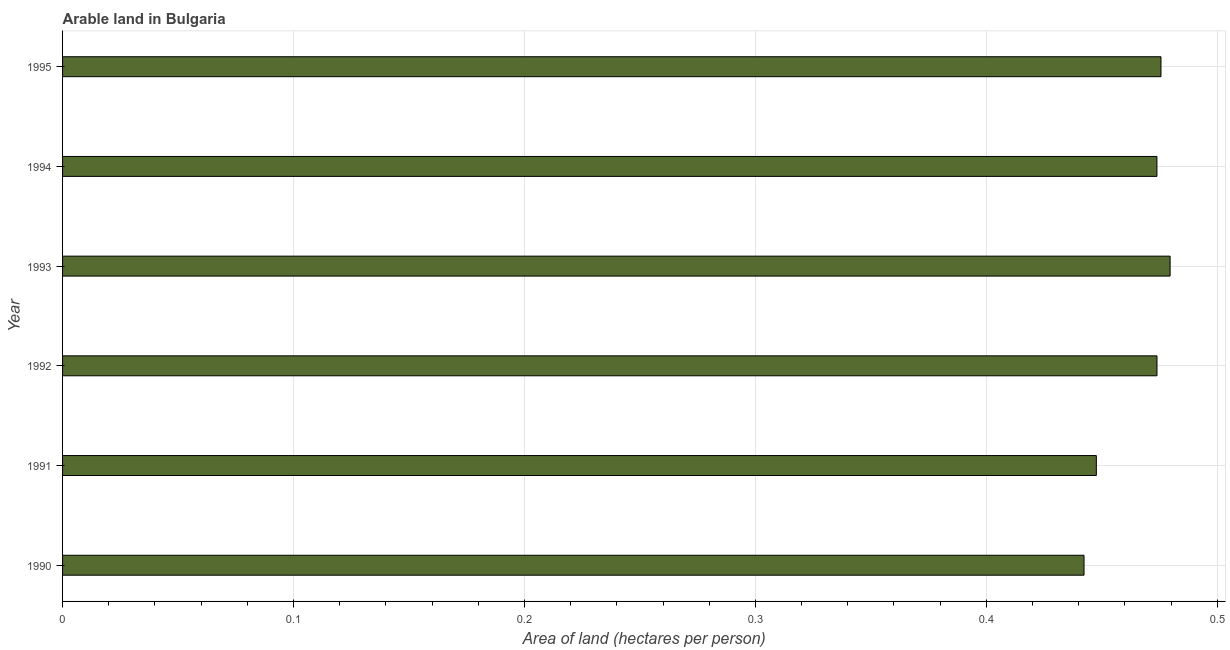What is the title of the graph?
Your response must be concise. Arable land in Bulgaria. What is the label or title of the X-axis?
Give a very brief answer. Area of land (hectares per person). What is the label or title of the Y-axis?
Offer a terse response. Year. What is the area of arable land in 1991?
Keep it short and to the point. 0.45. Across all years, what is the maximum area of arable land?
Provide a short and direct response. 0.48. Across all years, what is the minimum area of arable land?
Provide a succinct answer. 0.44. In which year was the area of arable land maximum?
Offer a very short reply. 1993. In which year was the area of arable land minimum?
Provide a short and direct response. 1990. What is the sum of the area of arable land?
Keep it short and to the point. 2.79. What is the difference between the area of arable land in 1990 and 1991?
Your response must be concise. -0.01. What is the average area of arable land per year?
Offer a terse response. 0.47. What is the median area of arable land?
Give a very brief answer. 0.47. What is the ratio of the area of arable land in 1990 to that in 1994?
Ensure brevity in your answer.  0.93. What is the difference between the highest and the second highest area of arable land?
Offer a very short reply. 0. Is the sum of the area of arable land in 1990 and 1991 greater than the maximum area of arable land across all years?
Offer a very short reply. Yes. What is the difference between the highest and the lowest area of arable land?
Keep it short and to the point. 0.04. In how many years, is the area of arable land greater than the average area of arable land taken over all years?
Keep it short and to the point. 4. How many bars are there?
Your response must be concise. 6. Are all the bars in the graph horizontal?
Keep it short and to the point. Yes. How many years are there in the graph?
Ensure brevity in your answer.  6. Are the values on the major ticks of X-axis written in scientific E-notation?
Ensure brevity in your answer.  No. What is the Area of land (hectares per person) of 1990?
Keep it short and to the point. 0.44. What is the Area of land (hectares per person) of 1991?
Your answer should be very brief. 0.45. What is the Area of land (hectares per person) in 1992?
Offer a very short reply. 0.47. What is the Area of land (hectares per person) of 1993?
Provide a succinct answer. 0.48. What is the Area of land (hectares per person) in 1994?
Offer a very short reply. 0.47. What is the Area of land (hectares per person) in 1995?
Your response must be concise. 0.48. What is the difference between the Area of land (hectares per person) in 1990 and 1991?
Offer a very short reply. -0.01. What is the difference between the Area of land (hectares per person) in 1990 and 1992?
Offer a very short reply. -0.03. What is the difference between the Area of land (hectares per person) in 1990 and 1993?
Your answer should be compact. -0.04. What is the difference between the Area of land (hectares per person) in 1990 and 1994?
Give a very brief answer. -0.03. What is the difference between the Area of land (hectares per person) in 1990 and 1995?
Your response must be concise. -0.03. What is the difference between the Area of land (hectares per person) in 1991 and 1992?
Provide a succinct answer. -0.03. What is the difference between the Area of land (hectares per person) in 1991 and 1993?
Offer a terse response. -0.03. What is the difference between the Area of land (hectares per person) in 1991 and 1994?
Keep it short and to the point. -0.03. What is the difference between the Area of land (hectares per person) in 1991 and 1995?
Give a very brief answer. -0.03. What is the difference between the Area of land (hectares per person) in 1992 and 1993?
Keep it short and to the point. -0.01. What is the difference between the Area of land (hectares per person) in 1992 and 1994?
Your answer should be very brief. 3e-5. What is the difference between the Area of land (hectares per person) in 1992 and 1995?
Your response must be concise. -0. What is the difference between the Area of land (hectares per person) in 1993 and 1994?
Your answer should be compact. 0.01. What is the difference between the Area of land (hectares per person) in 1993 and 1995?
Make the answer very short. 0. What is the difference between the Area of land (hectares per person) in 1994 and 1995?
Provide a succinct answer. -0. What is the ratio of the Area of land (hectares per person) in 1990 to that in 1992?
Offer a terse response. 0.93. What is the ratio of the Area of land (hectares per person) in 1990 to that in 1993?
Your answer should be compact. 0.92. What is the ratio of the Area of land (hectares per person) in 1990 to that in 1994?
Ensure brevity in your answer.  0.93. What is the ratio of the Area of land (hectares per person) in 1990 to that in 1995?
Your response must be concise. 0.93. What is the ratio of the Area of land (hectares per person) in 1991 to that in 1992?
Keep it short and to the point. 0.94. What is the ratio of the Area of land (hectares per person) in 1991 to that in 1993?
Keep it short and to the point. 0.93. What is the ratio of the Area of land (hectares per person) in 1991 to that in 1994?
Your answer should be compact. 0.94. What is the ratio of the Area of land (hectares per person) in 1991 to that in 1995?
Give a very brief answer. 0.94. What is the ratio of the Area of land (hectares per person) in 1992 to that in 1993?
Your answer should be compact. 0.99. What is the ratio of the Area of land (hectares per person) in 1992 to that in 1994?
Provide a short and direct response. 1. What is the ratio of the Area of land (hectares per person) in 1993 to that in 1994?
Your answer should be very brief. 1.01. What is the ratio of the Area of land (hectares per person) in 1993 to that in 1995?
Ensure brevity in your answer.  1.01. 